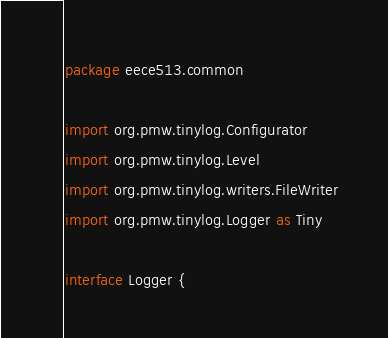<code> <loc_0><loc_0><loc_500><loc_500><_Kotlin_>package eece513.common

import org.pmw.tinylog.Configurator
import org.pmw.tinylog.Level
import org.pmw.tinylog.writers.FileWriter
import org.pmw.tinylog.Logger as Tiny

interface Logger {</code> 